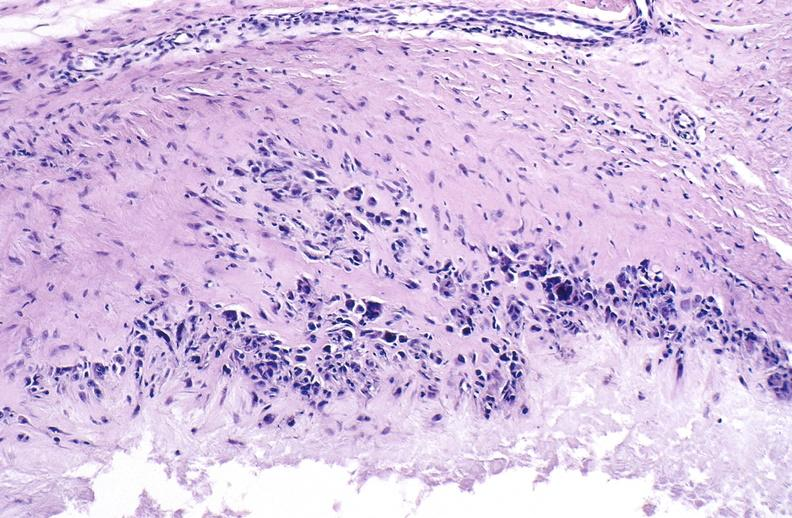does acute lymphocytic leukemia show gout?
Answer the question using a single word or phrase. No 